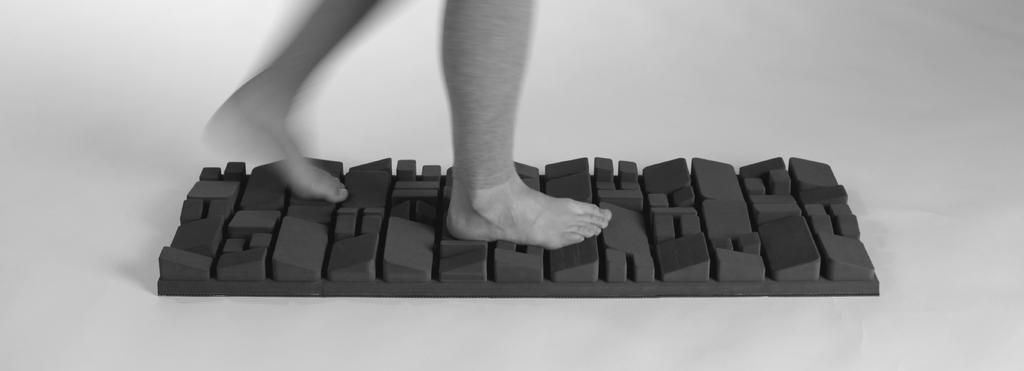What is the color scheme of the image? The image is black and white. What part of a person can be seen in the image? The legs of a person are visible in the image. What is the person's legs resting on? The legs are on an object. What color is the background of the image? The background of the image is white. What type of garden can be seen in the background of the image? There is no garden present in the image; it is a black and white image with a white background. 